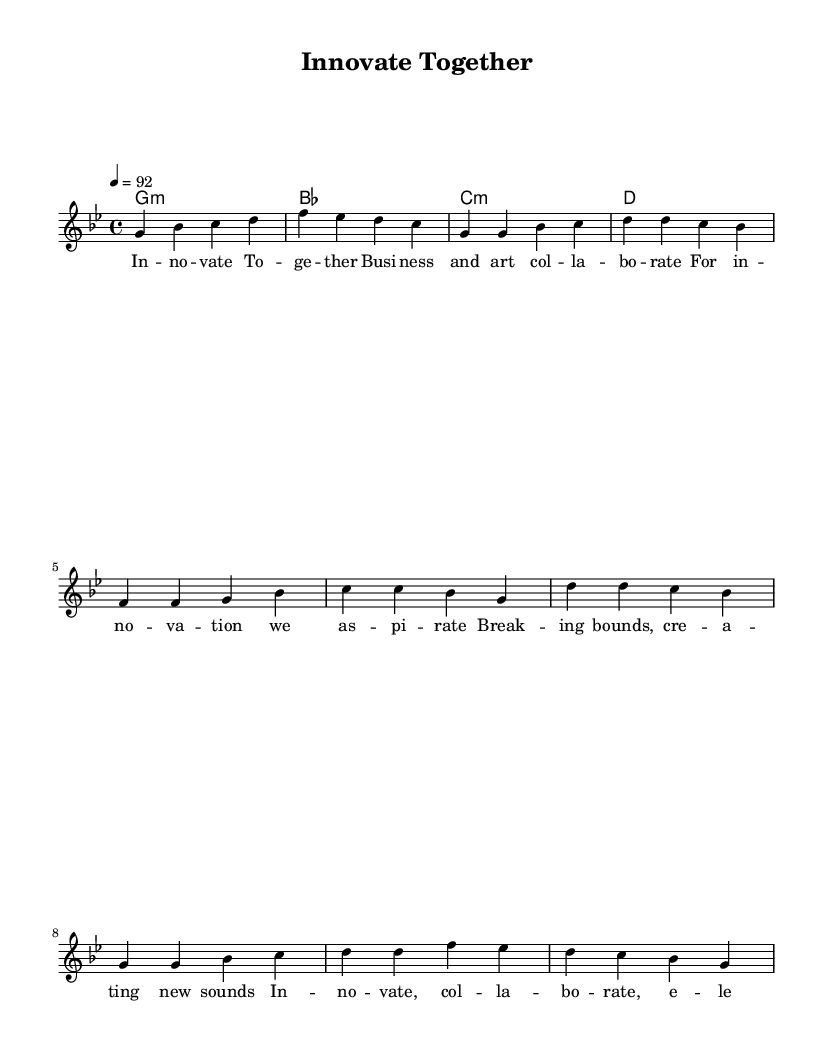What is the key signature of this music? The key signature is G minor, which has two flats (B flat and E flat). This is indicated at the beginning of the score.
Answer: G minor What is the time signature of this music? The time signature is 4/4, meaning there are four beats in each measure and the quarter note receives one beat. This can be found at the beginning of the score.
Answer: 4/4 What is the tempo marking of this piece? The tempo marking is 92 beats per minute, as indicated at the beginning of the score which tells performers the speed at which to play.
Answer: 92 How many measures are there in the chorus? The chorus consists of four measures, as counted from the notation provided under the melody section.
Answer: 4 What musical form does the piece follow? The piece follows a verse-chorus structure, which is common in hip hop music, where verses alternate with a repeated chorus. This format can be inferred from the lyrical sections labeled in the sheet music.
Answer: Verse-Chorus What thematic elements are expressed in the lyrics? The lyrics present themes of collaboration, innovation, and creativity between business and art, highlighting the merging of these fields. The content can be derived from the words provided in the lyric section.
Answer: Collaboration, innovation What is the primary purpose of this composition? The primary purpose is to highlight the collaboration between business leaders and artists in the pursuit of innovation, as reflected in the lyrics and overall message of the piece.
Answer: Innovation 